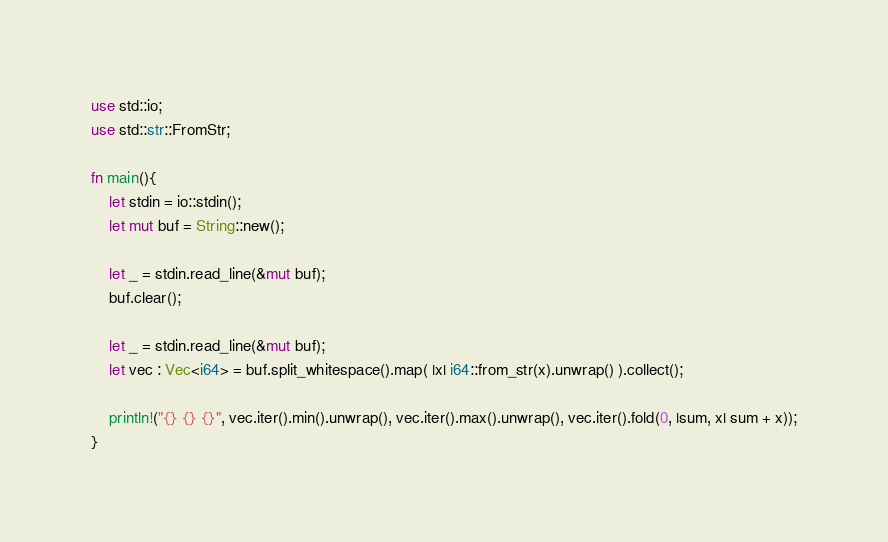Convert code to text. <code><loc_0><loc_0><loc_500><loc_500><_Rust_>use std::io;
use std::str::FromStr;

fn main(){
    let stdin = io::stdin();
    let mut buf = String::new();

    let _ = stdin.read_line(&mut buf);
    buf.clear();

    let _ = stdin.read_line(&mut buf);
    let vec : Vec<i64> = buf.split_whitespace().map( |x| i64::from_str(x).unwrap() ).collect();

    println!("{} {} {}", vec.iter().min().unwrap(), vec.iter().max().unwrap(), vec.iter().fold(0, |sum, x| sum + x));
}

</code> 